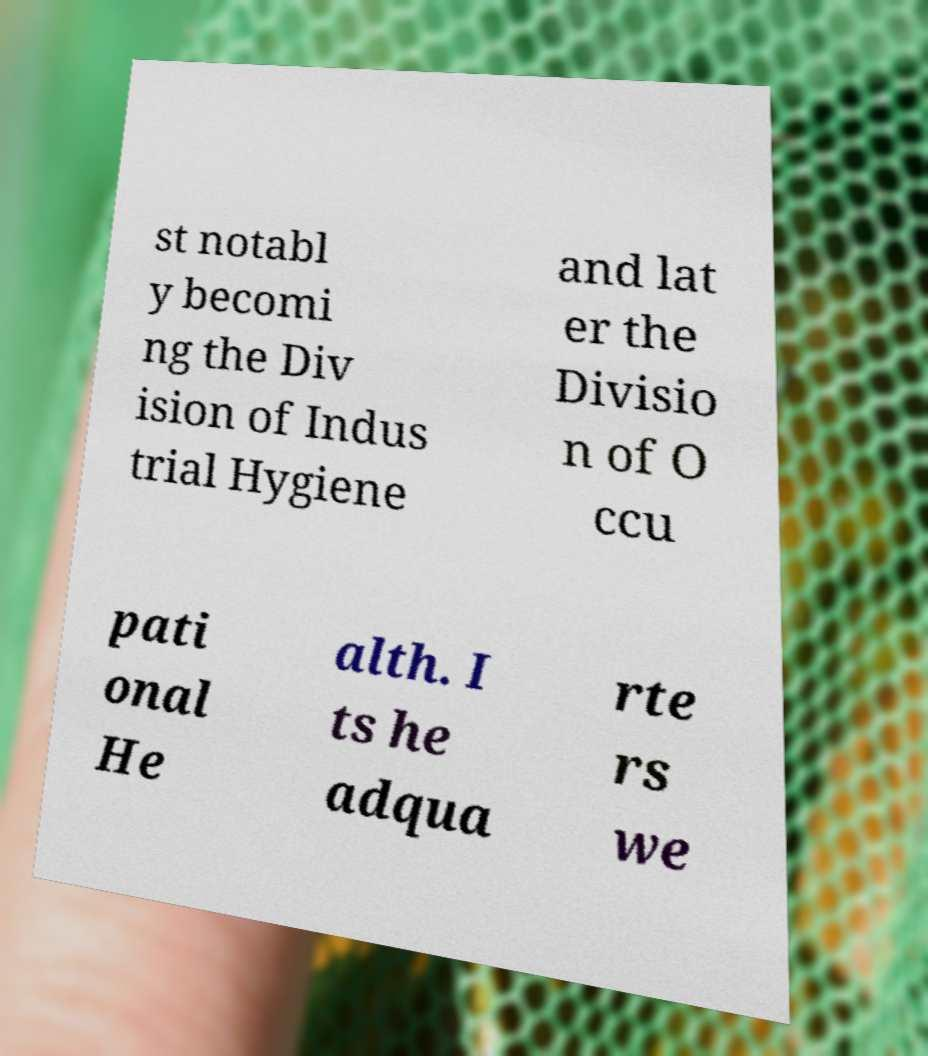What messages or text are displayed in this image? I need them in a readable, typed format. st notabl y becomi ng the Div ision of Indus trial Hygiene and lat er the Divisio n of O ccu pati onal He alth. I ts he adqua rte rs we 